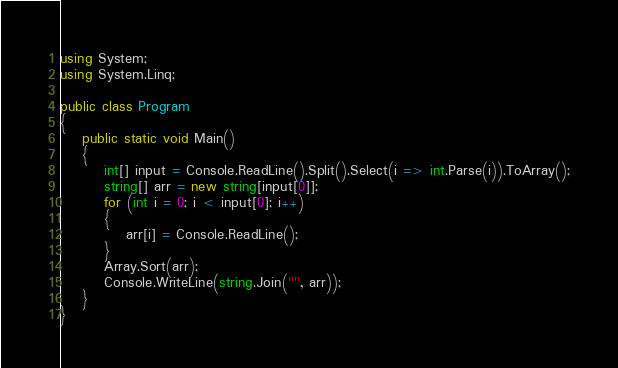Convert code to text. <code><loc_0><loc_0><loc_500><loc_500><_C#_>using System;
using System.Linq;
 
public class Program
{
	public static void Main()
	{
		int[] input = Console.ReadLine().Split().Select(i => int.Parse(i)).ToArray();
		string[] arr = new string[input[0]];
		for (int i = 0; i < input[0]; i++)
		{
			arr[i] = Console.ReadLine();
		}
		Array.Sort(arr);
		Console.WriteLine(string.Join("", arr));
	}
}</code> 